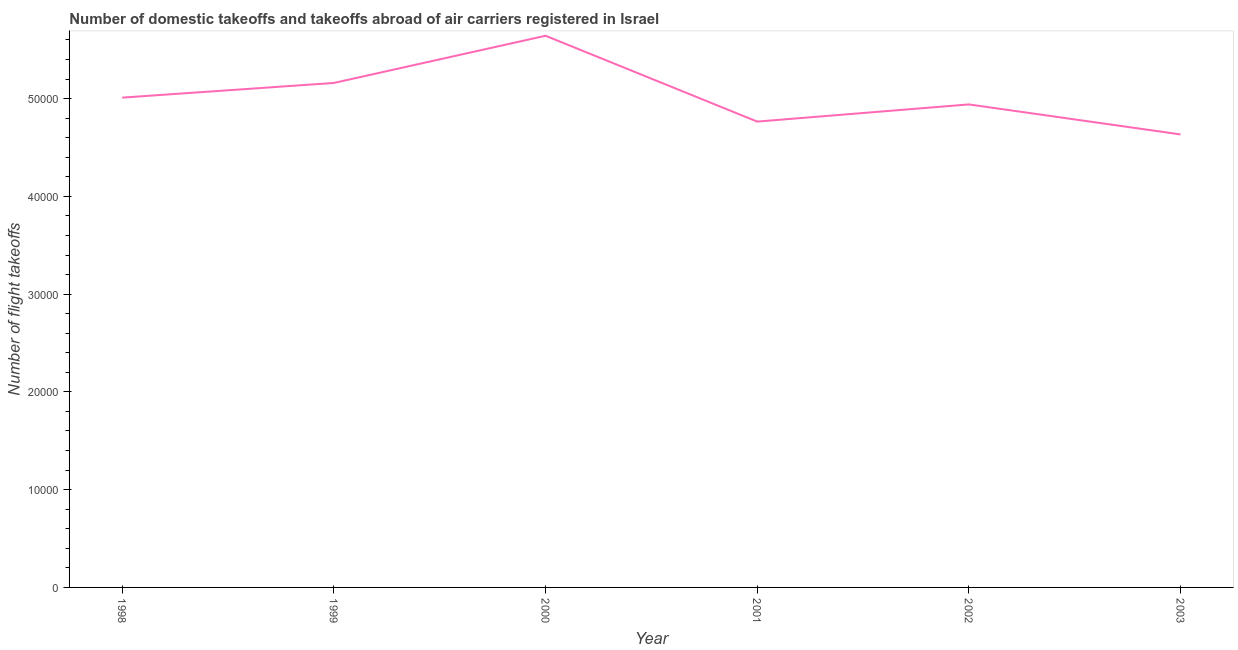What is the number of flight takeoffs in 1998?
Offer a very short reply. 5.01e+04. Across all years, what is the maximum number of flight takeoffs?
Your response must be concise. 5.64e+04. Across all years, what is the minimum number of flight takeoffs?
Your answer should be very brief. 4.63e+04. What is the sum of the number of flight takeoffs?
Your response must be concise. 3.02e+05. What is the difference between the number of flight takeoffs in 2002 and 2003?
Offer a very short reply. 3070. What is the average number of flight takeoffs per year?
Give a very brief answer. 5.03e+04. What is the median number of flight takeoffs?
Ensure brevity in your answer.  4.98e+04. In how many years, is the number of flight takeoffs greater than 8000 ?
Provide a succinct answer. 6. What is the ratio of the number of flight takeoffs in 1999 to that in 2001?
Your response must be concise. 1.08. Is the difference between the number of flight takeoffs in 1999 and 2000 greater than the difference between any two years?
Your response must be concise. No. What is the difference between the highest and the second highest number of flight takeoffs?
Your response must be concise. 4827. What is the difference between the highest and the lowest number of flight takeoffs?
Provide a succinct answer. 1.01e+04. Does the number of flight takeoffs monotonically increase over the years?
Your answer should be compact. No. How many lines are there?
Provide a short and direct response. 1. How many years are there in the graph?
Your response must be concise. 6. What is the difference between two consecutive major ticks on the Y-axis?
Offer a terse response. 10000. Are the values on the major ticks of Y-axis written in scientific E-notation?
Your answer should be compact. No. Does the graph contain grids?
Your answer should be compact. No. What is the title of the graph?
Provide a succinct answer. Number of domestic takeoffs and takeoffs abroad of air carriers registered in Israel. What is the label or title of the Y-axis?
Offer a very short reply. Number of flight takeoffs. What is the Number of flight takeoffs in 1998?
Keep it short and to the point. 5.01e+04. What is the Number of flight takeoffs in 1999?
Make the answer very short. 5.16e+04. What is the Number of flight takeoffs in 2000?
Your answer should be very brief. 5.64e+04. What is the Number of flight takeoffs in 2001?
Your answer should be very brief. 4.76e+04. What is the Number of flight takeoffs in 2002?
Offer a very short reply. 4.94e+04. What is the Number of flight takeoffs of 2003?
Offer a very short reply. 4.63e+04. What is the difference between the Number of flight takeoffs in 1998 and 1999?
Give a very brief answer. -1500. What is the difference between the Number of flight takeoffs in 1998 and 2000?
Offer a terse response. -6327. What is the difference between the Number of flight takeoffs in 1998 and 2001?
Your response must be concise. 2452. What is the difference between the Number of flight takeoffs in 1998 and 2002?
Offer a terse response. 696. What is the difference between the Number of flight takeoffs in 1998 and 2003?
Offer a terse response. 3766. What is the difference between the Number of flight takeoffs in 1999 and 2000?
Provide a short and direct response. -4827. What is the difference between the Number of flight takeoffs in 1999 and 2001?
Offer a very short reply. 3952. What is the difference between the Number of flight takeoffs in 1999 and 2002?
Provide a short and direct response. 2196. What is the difference between the Number of flight takeoffs in 1999 and 2003?
Your answer should be very brief. 5266. What is the difference between the Number of flight takeoffs in 2000 and 2001?
Make the answer very short. 8779. What is the difference between the Number of flight takeoffs in 2000 and 2002?
Offer a very short reply. 7023. What is the difference between the Number of flight takeoffs in 2000 and 2003?
Offer a terse response. 1.01e+04. What is the difference between the Number of flight takeoffs in 2001 and 2002?
Give a very brief answer. -1756. What is the difference between the Number of flight takeoffs in 2001 and 2003?
Your answer should be very brief. 1314. What is the difference between the Number of flight takeoffs in 2002 and 2003?
Give a very brief answer. 3070. What is the ratio of the Number of flight takeoffs in 1998 to that in 2000?
Make the answer very short. 0.89. What is the ratio of the Number of flight takeoffs in 1998 to that in 2001?
Provide a succinct answer. 1.05. What is the ratio of the Number of flight takeoffs in 1998 to that in 2003?
Your response must be concise. 1.08. What is the ratio of the Number of flight takeoffs in 1999 to that in 2000?
Your answer should be very brief. 0.91. What is the ratio of the Number of flight takeoffs in 1999 to that in 2001?
Provide a short and direct response. 1.08. What is the ratio of the Number of flight takeoffs in 1999 to that in 2002?
Your answer should be very brief. 1.04. What is the ratio of the Number of flight takeoffs in 1999 to that in 2003?
Provide a succinct answer. 1.11. What is the ratio of the Number of flight takeoffs in 2000 to that in 2001?
Make the answer very short. 1.18. What is the ratio of the Number of flight takeoffs in 2000 to that in 2002?
Provide a short and direct response. 1.14. What is the ratio of the Number of flight takeoffs in 2000 to that in 2003?
Give a very brief answer. 1.22. What is the ratio of the Number of flight takeoffs in 2001 to that in 2002?
Offer a very short reply. 0.96. What is the ratio of the Number of flight takeoffs in 2001 to that in 2003?
Provide a short and direct response. 1.03. What is the ratio of the Number of flight takeoffs in 2002 to that in 2003?
Ensure brevity in your answer.  1.07. 